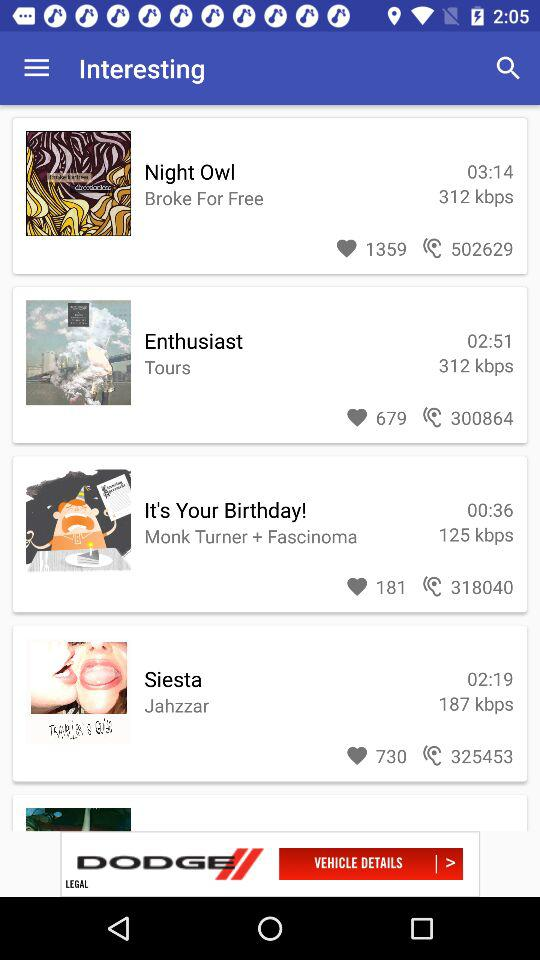What is the time duration of the "Siesta"? The time duration of the "Siesta" is 02:19. 